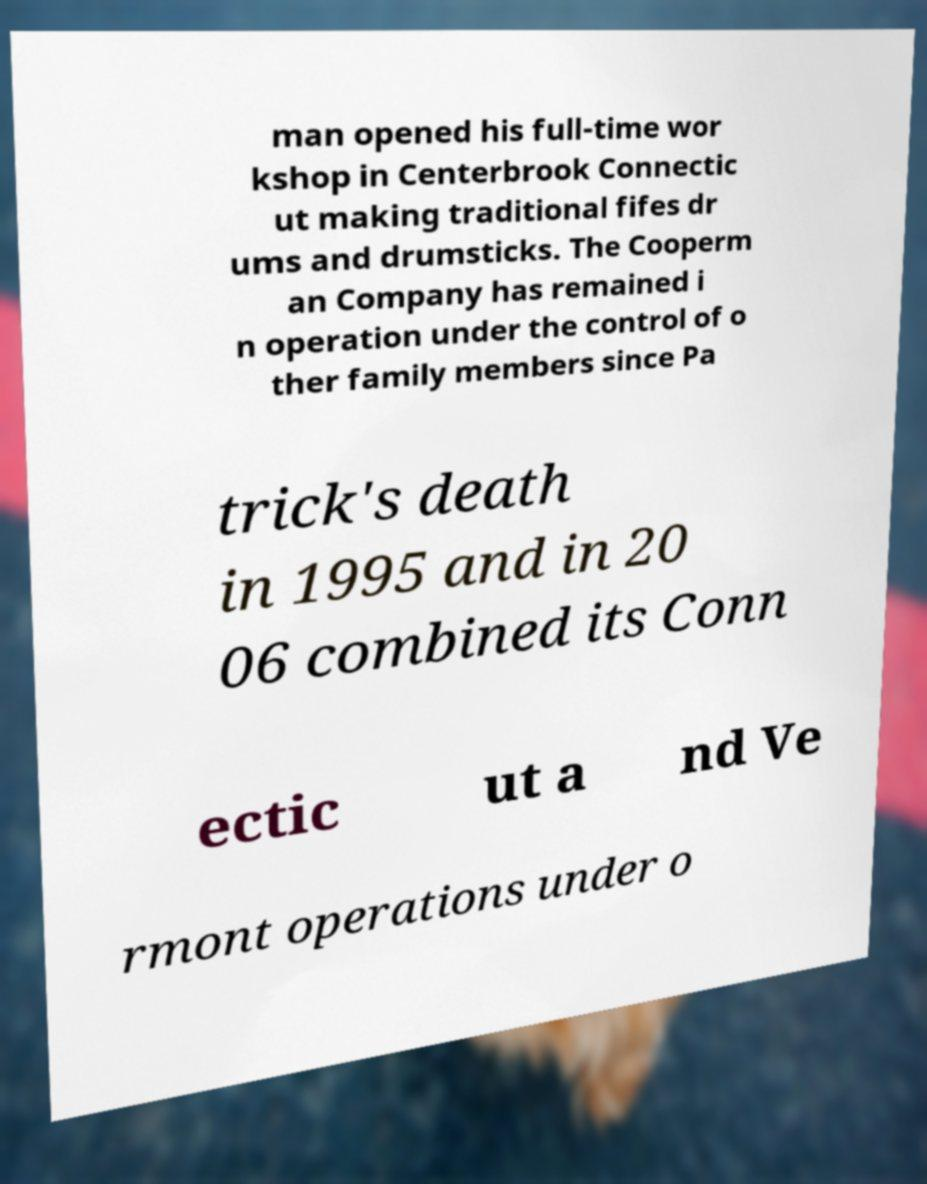What messages or text are displayed in this image? I need them in a readable, typed format. man opened his full-time wor kshop in Centerbrook Connectic ut making traditional fifes dr ums and drumsticks. The Cooperm an Company has remained i n operation under the control of o ther family members since Pa trick's death in 1995 and in 20 06 combined its Conn ectic ut a nd Ve rmont operations under o 